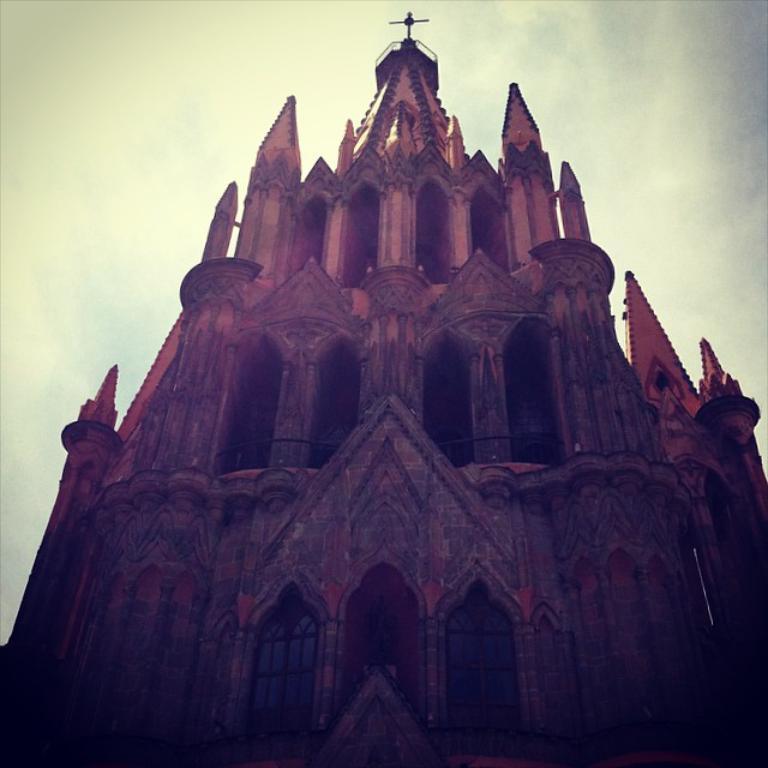Could you give a brief overview of what you see in this image? In the center of the image there is a fort. In the background there is sky. 